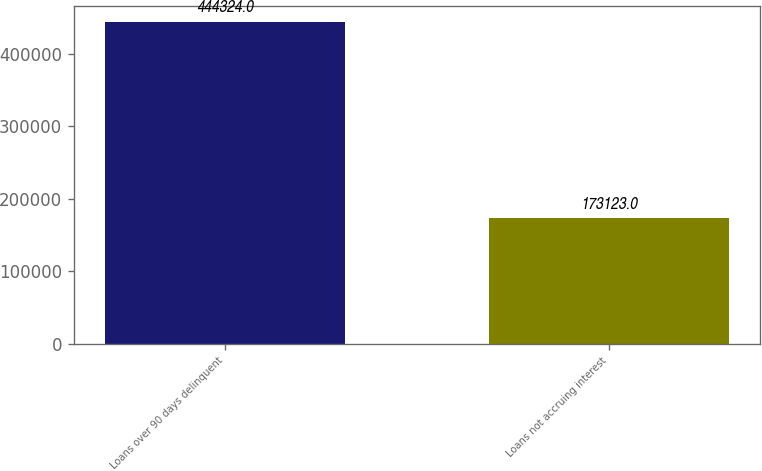<chart> <loc_0><loc_0><loc_500><loc_500><bar_chart><fcel>Loans over 90 days delinquent<fcel>Loans not accruing interest<nl><fcel>444324<fcel>173123<nl></chart> 